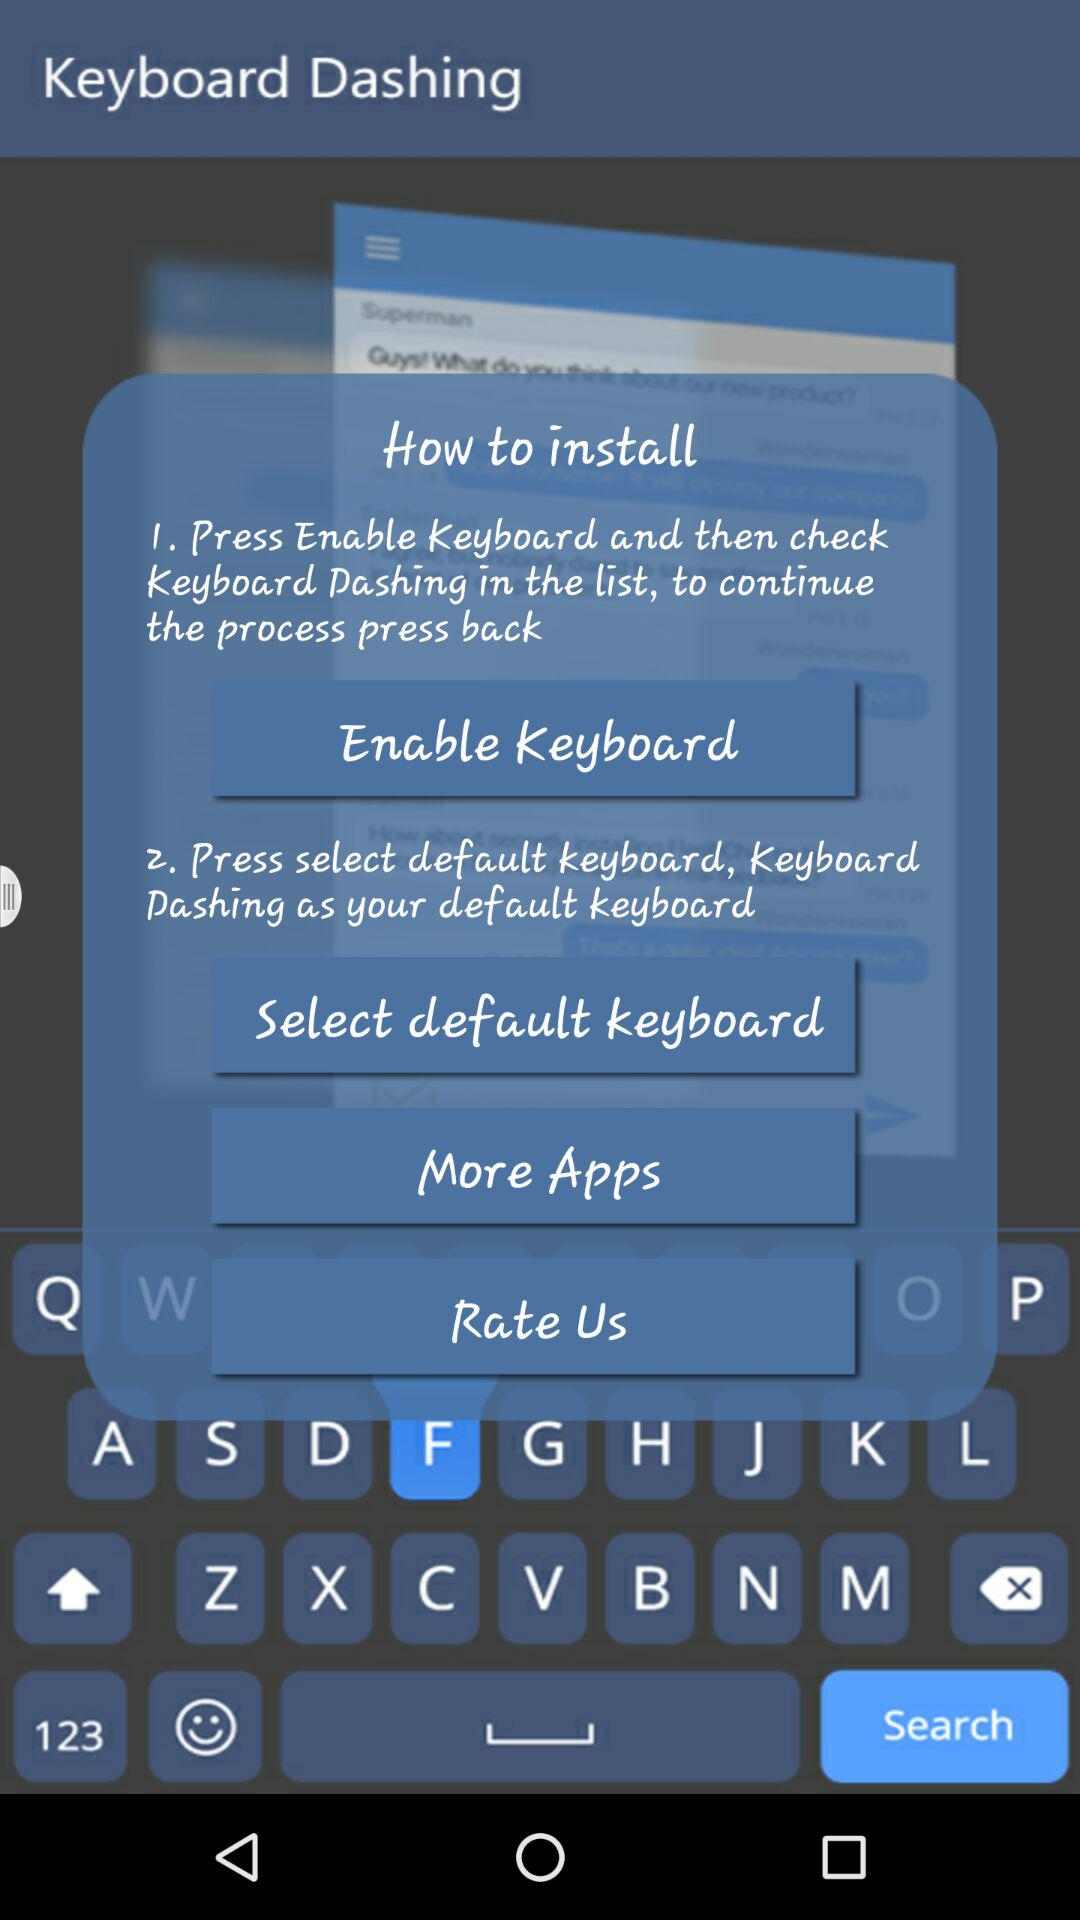How many steps are there in the installation process?
Answer the question using a single word or phrase. 2 